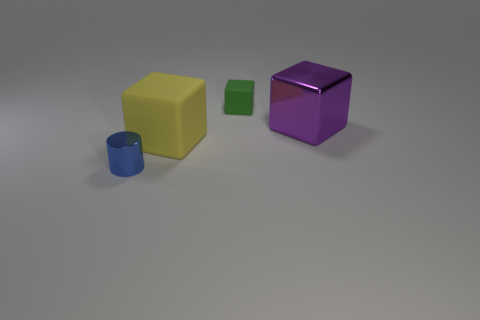Add 1 small matte objects. How many objects exist? 5 Subtract all yellow matte blocks. How many blocks are left? 2 Subtract 1 cylinders. How many cylinders are left? 0 Subtract all blue cylinders. How many red blocks are left? 0 Subtract all tiny yellow rubber cylinders. Subtract all large yellow objects. How many objects are left? 3 Add 2 purple shiny things. How many purple shiny things are left? 3 Add 4 green objects. How many green objects exist? 5 Subtract all purple blocks. How many blocks are left? 2 Subtract 1 green cubes. How many objects are left? 3 Subtract all cylinders. How many objects are left? 3 